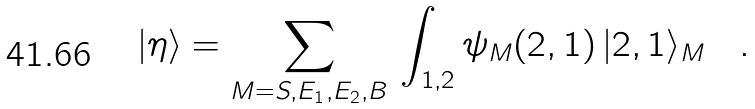<formula> <loc_0><loc_0><loc_500><loc_500>| \eta \rangle = \sum _ { M = S , E _ { 1 } , E _ { 2 } , B } \, \int _ { 1 , 2 } \psi _ { M } ( 2 , 1 ) \, | 2 , 1 \rangle _ { M } \quad .</formula> 